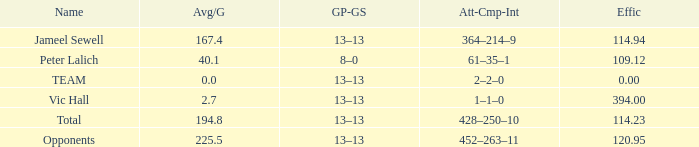Avg/G smaller than 225.5, and a GP-GS of 8–0 has what name? Peter Lalich. 